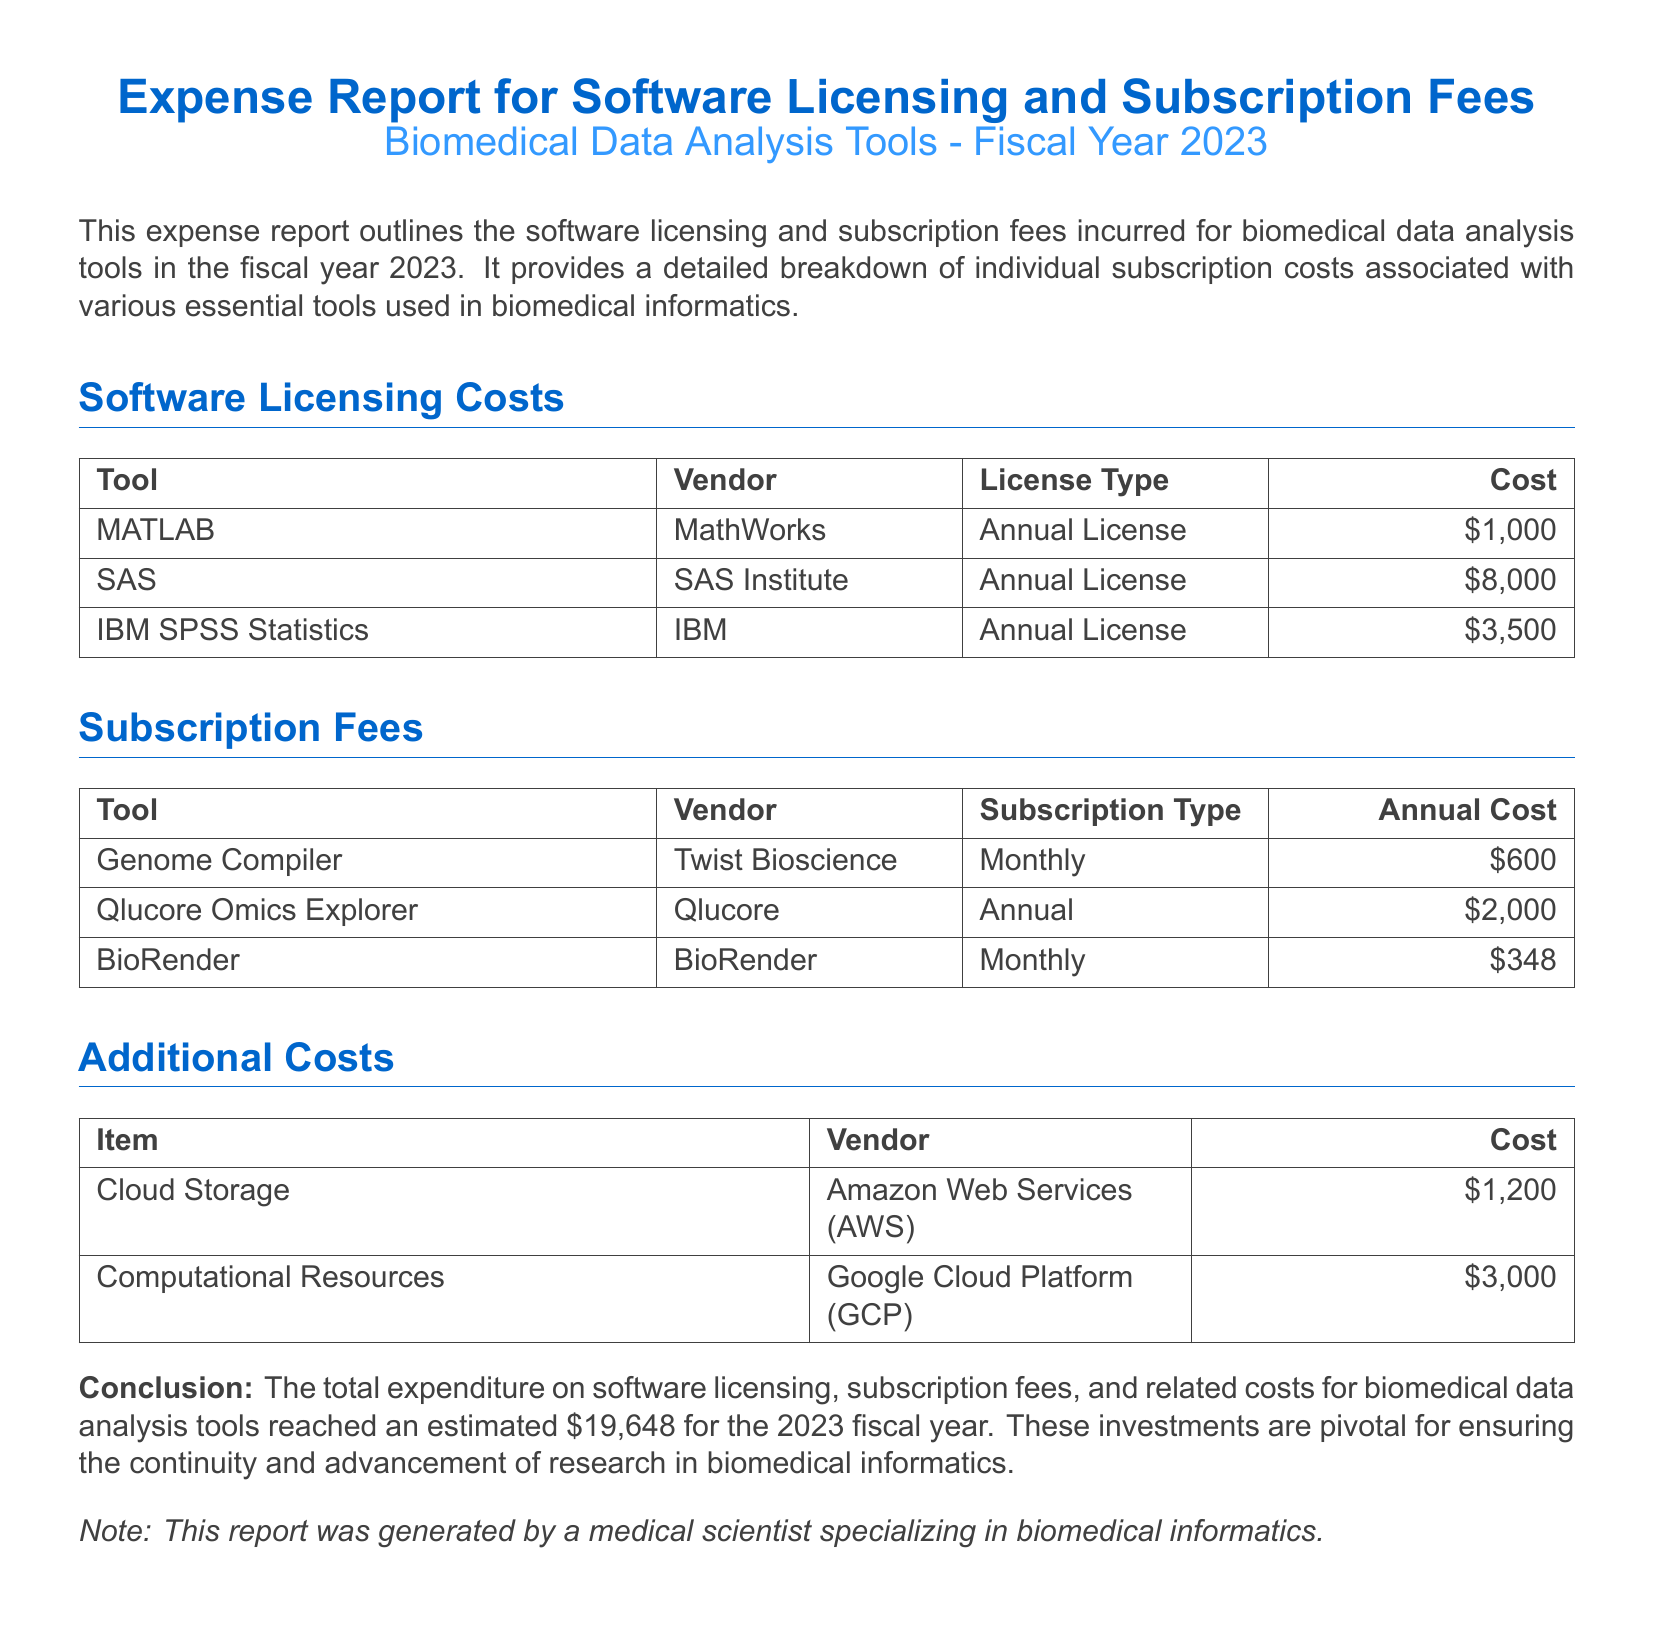What is the total expenditure for the fiscal year 2023? The total expenditure is explicitly stated in the conclusion section of the document.
Answer: $19,648 What is the cost of the SAS license? The specific cost for the SAS license is listed in the software licensing costs table.
Answer: $8,000 Who is the vendor for BioRender? The vendor for BioRender is mentioned in the subscription fees table.
Answer: BioRender How many software tools are listed under Software Licensing Costs? The number of tools can be counted from the software licensing costs table.
Answer: 3 What is the cost of Genome Compiler for a year? The cost of Genome Compiler is detailed in the subscription fees section, stated per month.
Answer: $600 Which vendor provides Computational Resources? The vendor for Computational Resources is indicated in the additional costs section of the report.
Answer: Google Cloud Platform What type of license does IBM SPSS Statistics have? The type of license is specified in the software licensing costs table alongside the tool name.
Answer: Annual License How much does Qlucore Omics Explorer cost annually? This amount is specified in the subscription fees section under Qlucore Omics Explorer.
Answer: $2,000 What is the cost of Cloud Storage? The cost listed in the additional costs section corresponds to Cloud Storage.
Answer: $1,200 